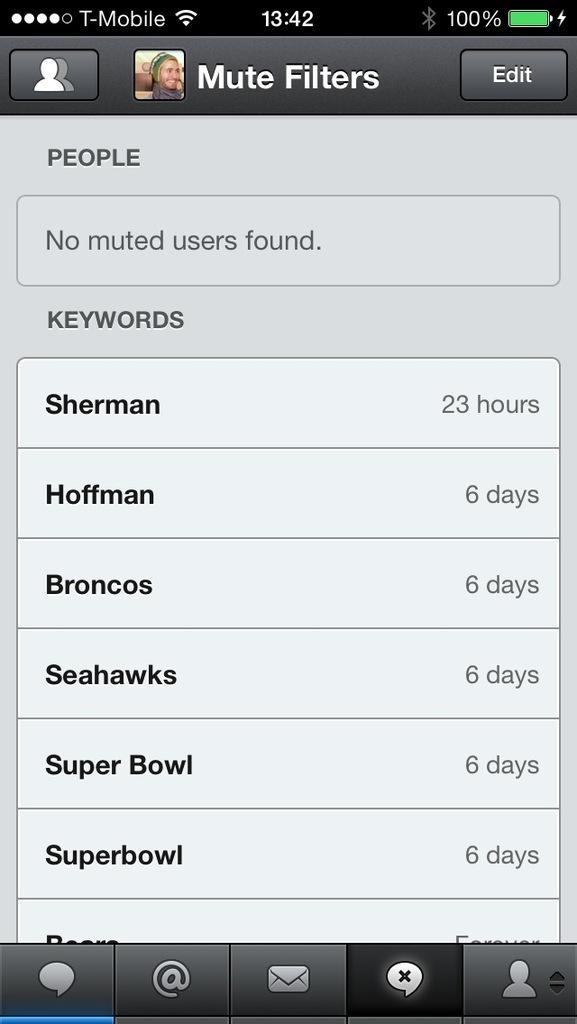<image>
Create a compact narrative representing the image presented. The mute filters option is on the screen 